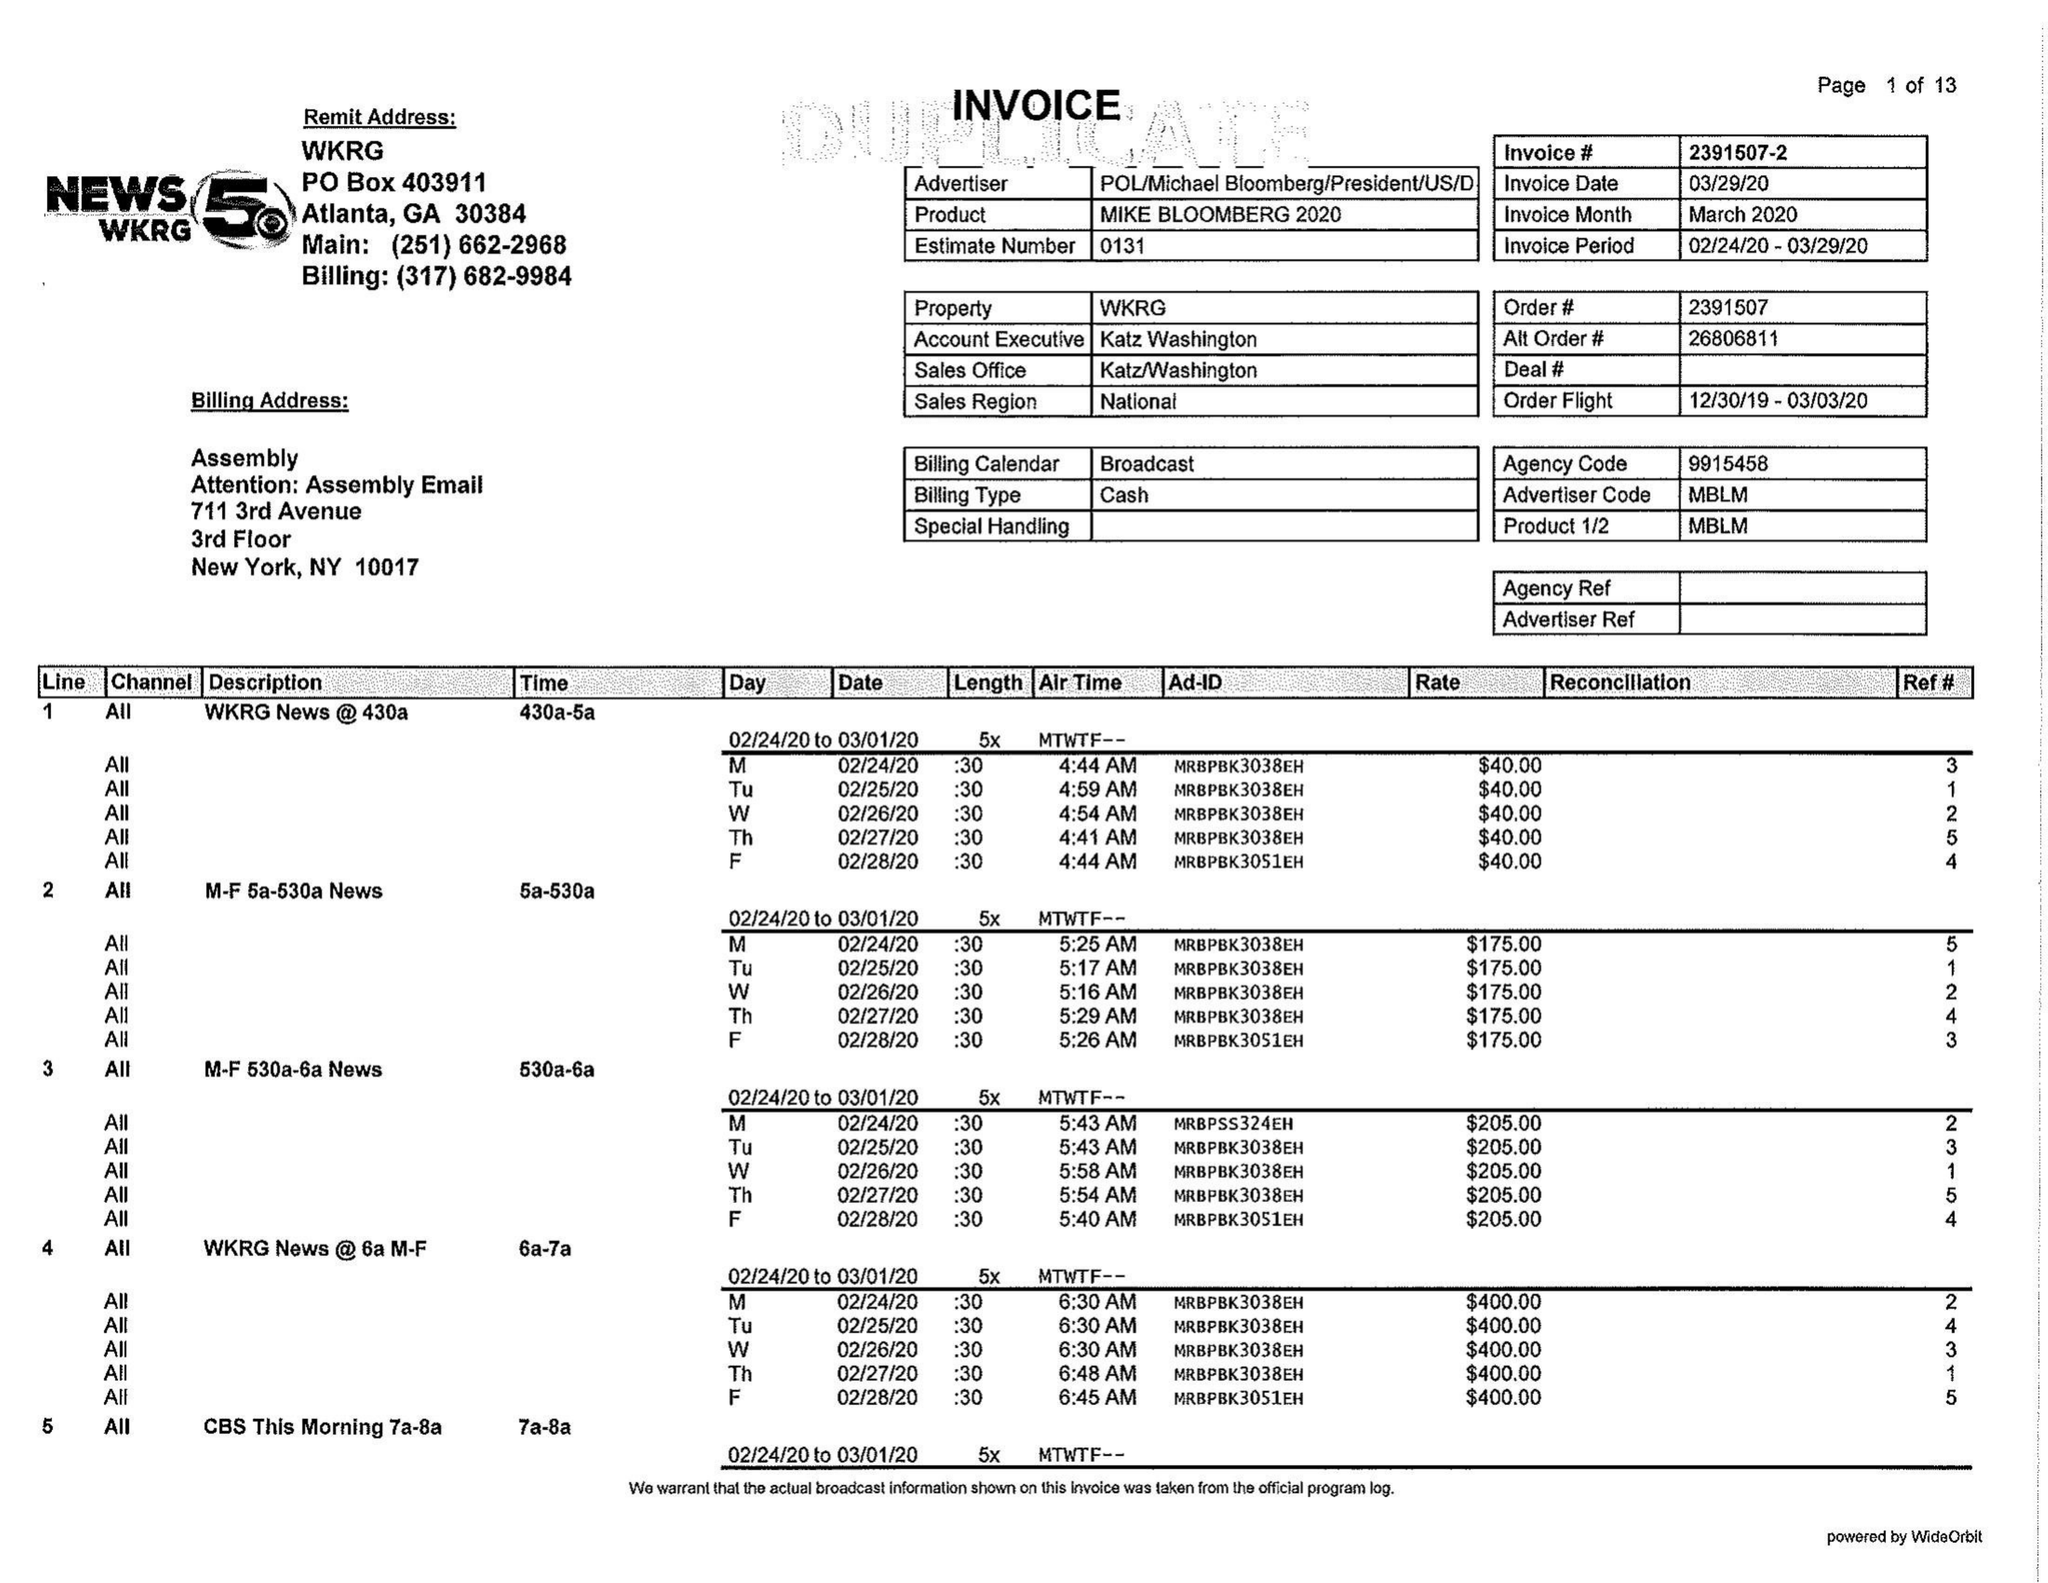What is the value for the advertiser?
Answer the question using a single word or phrase. POL/MICHAELBLOOMBERG/PRESIDENT/US/D 